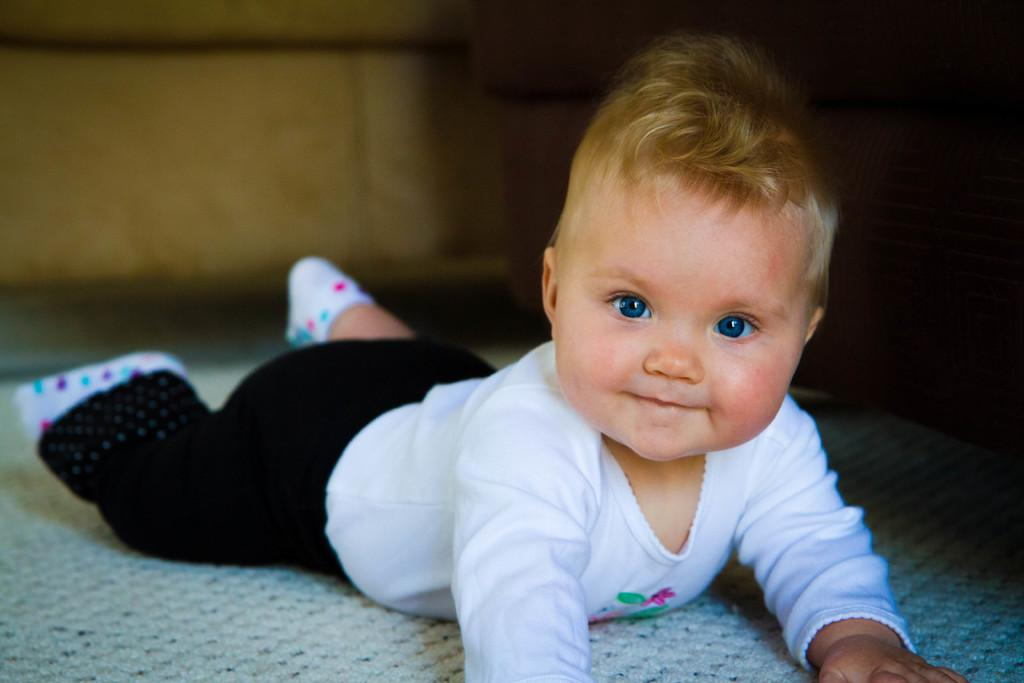What is the main subject of the image? There is a baby in the image. What is the baby's position in the image? The baby is lying on a mat. What is the baby's focus in the image? The baby is watching something. How would you describe the background in the image? The background in the image is blurred. What type of nation is depicted in the background of the image? There is no nation depicted in the image; the background is blurred. What direction is the zephyr blowing in the image? There is no zephyr present in the image. 